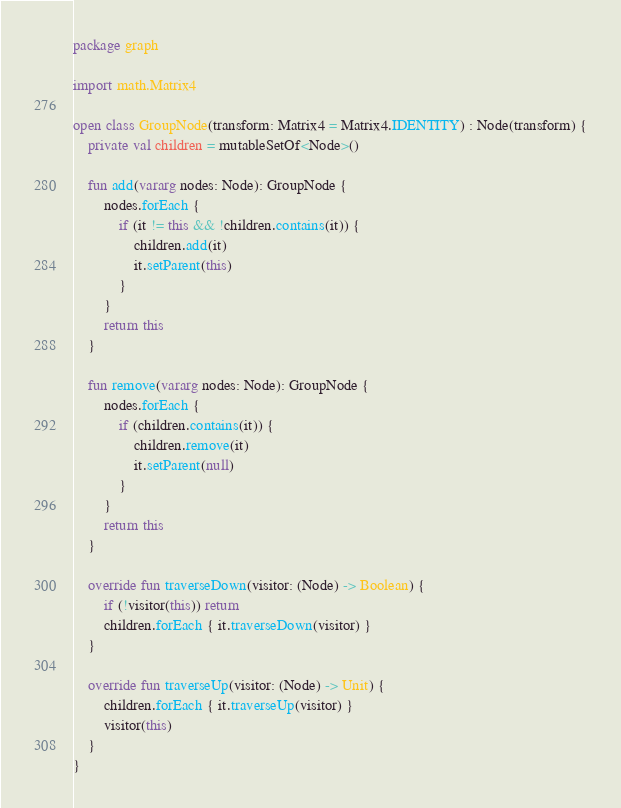<code> <loc_0><loc_0><loc_500><loc_500><_Kotlin_>package graph

import math.Matrix4

open class GroupNode(transform: Matrix4 = Matrix4.IDENTITY) : Node(transform) {
    private val children = mutableSetOf<Node>()

    fun add(vararg nodes: Node): GroupNode {
        nodes.forEach {
            if (it != this && !children.contains(it)) {
                children.add(it)
                it.setParent(this)
            }
        }
        return this
    }

    fun remove(vararg nodes: Node): GroupNode {
        nodes.forEach {
            if (children.contains(it)) {
                children.remove(it)
                it.setParent(null)
            }
        }
        return this
    }

    override fun traverseDown(visitor: (Node) -> Boolean) {
        if (!visitor(this)) return
        children.forEach { it.traverseDown(visitor) }
    }

    override fun traverseUp(visitor: (Node) -> Unit) {
        children.forEach { it.traverseUp(visitor) }
        visitor(this)
    }
}
</code> 